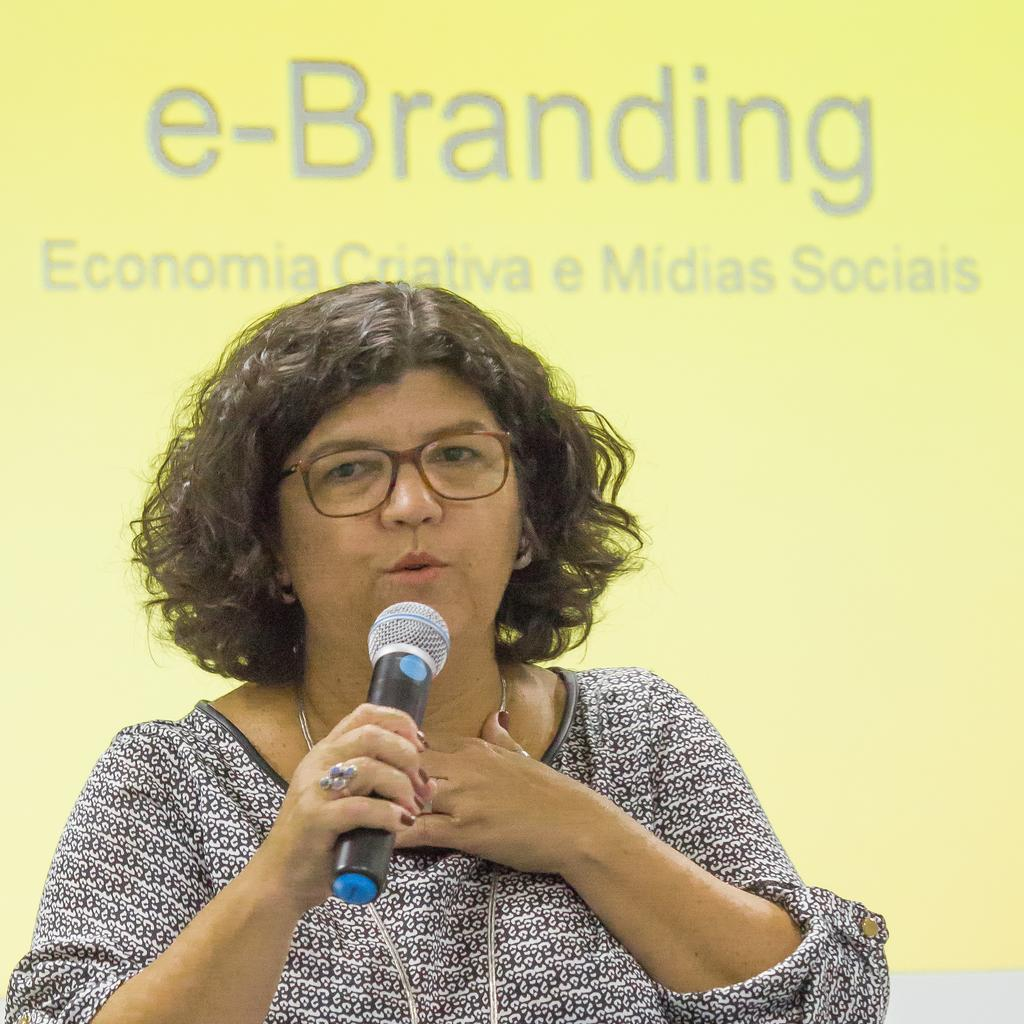Who is the main subject in the image? There is a woman in the image. What is the woman doing in the image? The woman is speaking in the image. What tool is the woman using to amplify her voice? The woman is using a microphone in the image. What can be seen in the background of the image? There is text visible in the background of the image. What type of quilt is the woman using to cover her lap in the image? There is no quilt present in the image; the woman is using a microphone to amplify her voice. 